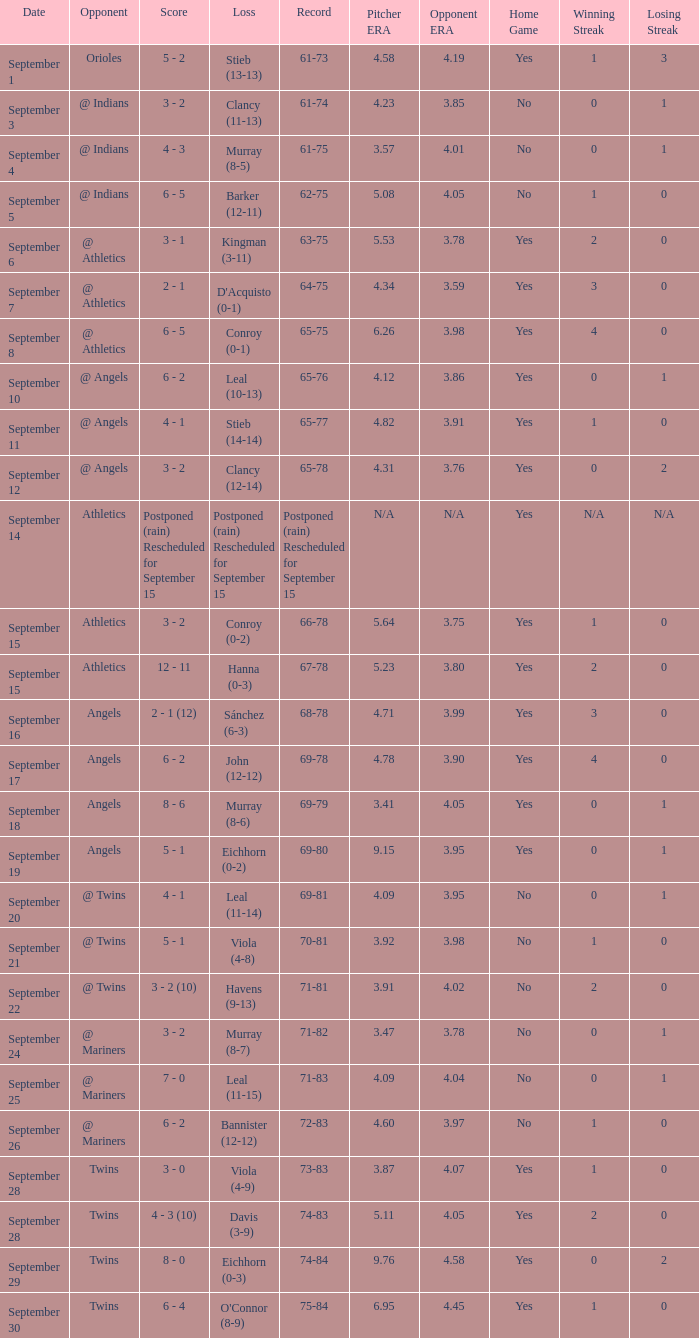Could you parse the entire table? {'header': ['Date', 'Opponent', 'Score', 'Loss', 'Record', 'Pitcher ERA', 'Opponent ERA', 'Home Game', 'Winning Streak', 'Losing Streak'], 'rows': [['September 1', 'Orioles', '5 - 2', 'Stieb (13-13)', '61-73', '4.58', '4.19', 'Yes', '1', '3'], ['September 3', '@ Indians', '3 - 2', 'Clancy (11-13)', '61-74', '4.23', '3.85', 'No', '0', '1'], ['September 4', '@ Indians', '4 - 3', 'Murray (8-5)', '61-75', '3.57', '4.01', 'No', '0', '1'], ['September 5', '@ Indians', '6 - 5', 'Barker (12-11)', '62-75', '5.08', '4.05', 'No', '1', '0'], ['September 6', '@ Athletics', '3 - 1', 'Kingman (3-11)', '63-75', '5.53', '3.78', 'Yes', '2', '0'], ['September 7', '@ Athletics', '2 - 1', "D'Acquisto (0-1)", '64-75', '4.34', '3.59', 'Yes', '3', '0'], ['September 8', '@ Athletics', '6 - 5', 'Conroy (0-1)', '65-75', '6.26', '3.98', 'Yes', '4', '0'], ['September 10', '@ Angels', '6 - 2', 'Leal (10-13)', '65-76', '4.12', '3.86', 'Yes', '0', '1'], ['September 11', '@ Angels', '4 - 1', 'Stieb (14-14)', '65-77', '4.82', '3.91', 'Yes', '1', '0'], ['September 12', '@ Angels', '3 - 2', 'Clancy (12-14)', '65-78', '4.31', '3.76', 'Yes', '0', '2'], ['September 14', 'Athletics', 'Postponed (rain) Rescheduled for September 15', 'Postponed (rain) Rescheduled for September 15', 'Postponed (rain) Rescheduled for September 15', 'N/A', 'N/A', 'Yes', 'N/A', 'N/A'], ['September 15', 'Athletics', '3 - 2', 'Conroy (0-2)', '66-78', '5.64', '3.75', 'Yes', '1', '0'], ['September 15', 'Athletics', '12 - 11', 'Hanna (0-3)', '67-78', '5.23', '3.80', 'Yes', '2', '0'], ['September 16', 'Angels', '2 - 1 (12)', 'Sánchez (6-3)', '68-78', '4.71', '3.99', 'Yes', '3', '0'], ['September 17', 'Angels', '6 - 2', 'John (12-12)', '69-78', '4.78', '3.90', 'Yes', '4', '0'], ['September 18', 'Angels', '8 - 6', 'Murray (8-6)', '69-79', '3.41', '4.05', 'Yes', '0', '1'], ['September 19', 'Angels', '5 - 1', 'Eichhorn (0-2)', '69-80', '9.15', '3.95', 'Yes', '0', '1'], ['September 20', '@ Twins', '4 - 1', 'Leal (11-14)', '69-81', '4.09', '3.95', 'No', '0', '1'], ['September 21', '@ Twins', '5 - 1', 'Viola (4-8)', '70-81', '3.92', '3.98', 'No', '1', '0'], ['September 22', '@ Twins', '3 - 2 (10)', 'Havens (9-13)', '71-81', '3.91', '4.02', 'No', '2', '0'], ['September 24', '@ Mariners', '3 - 2', 'Murray (8-7)', '71-82', '3.47', '3.78', 'No', '0', '1'], ['September 25', '@ Mariners', '7 - 0', 'Leal (11-15)', '71-83', '4.09', '4.04', 'No', '0', '1'], ['September 26', '@ Mariners', '6 - 2', 'Bannister (12-12)', '72-83', '4.60', '3.97', 'No', '1', '0'], ['September 28', 'Twins', '3 - 0', 'Viola (4-9)', '73-83', '3.87', '4.07', 'Yes', '1', '0'], ['September 28', 'Twins', '4 - 3 (10)', 'Davis (3-9)', '74-83', '5.11', '4.05', 'Yes', '2', '0'], ['September 29', 'Twins', '8 - 0', 'Eichhorn (0-3)', '74-84', '9.76', '4.58', 'Yes', '0', '2'], ['September 30', 'Twins', '6 - 4', "O'Connor (8-9)", '75-84', '6.95', '4.45', 'Yes', '1', '0']]} Name the score for september 11 4 - 1. 